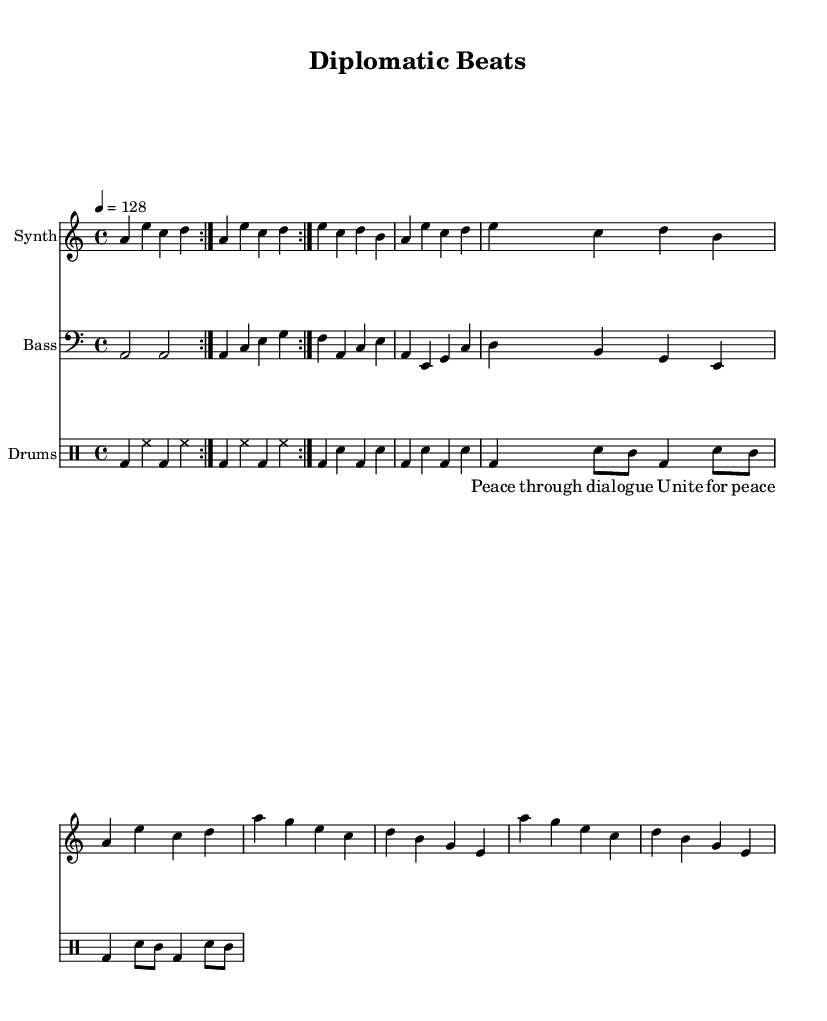What is the key signature of this music? The key signature indicates that the piece is in A minor, which has no sharps or flats. This can be confirmed by looking at the key signature section in the sheet music, where it shows an A with no accidentals.
Answer: A minor What is the time signature of this music? The time signature is found at the beginning of the music and is indicated as 4/4, which means there are four beats in each measure and the quarter note gets one beat. This is commonly used in house music for its steady rhythm.
Answer: 4/4 What is the tempo marking of this piece? The tempo marking is provided in the sheet music and indicates a speed of 128 beats per minute. This is a common tempo for house music, providing a lively and energetic pace.
Answer: 128 How many volta sections are present in the intro? The intro has a repeat indicated by the "volta" marking, which specifies that it should be played twice. This means there are two volta sections in the intro.
Answer: 2 Which instrument is playing the bass part? The bass part is played by a clef that is specified as "bass" in the sheet music. This notation indicates that the instrument accompanying the melody is most likely a bass synthesizer or sampler, common in house music.
Answer: Bass What is the primary theme expressed in the vocal sample? The vocal sample expresses the theme of peace and unity, as indicated by the lyrics "Peace through dialogue" and "Unite for peace". This aligns with the broader themes of diplomacy and conflict resolution indicated in the title "Diplomatic Beats".
Answer: Peace and unity What rhythmic pattern is used in the drum part? The drum part is characterized by a four-on-the-floor pattern, where the bass drum is hit on every beat, providing a steady and driving rhythm typical in house music. This pattern is crucial for maintaining energy on the dance floor.
Answer: Four-on-the-floor 